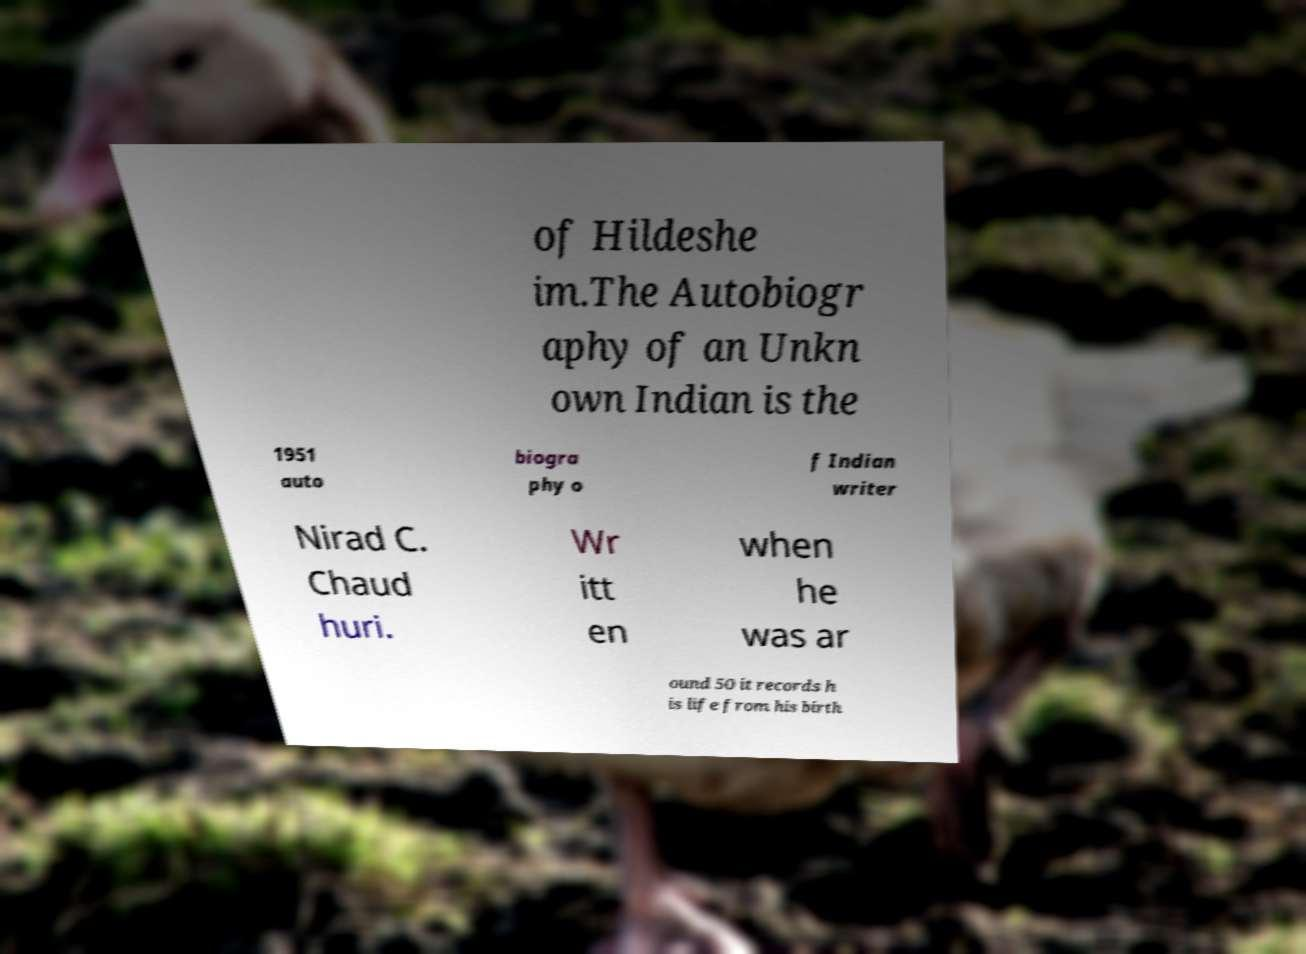I need the written content from this picture converted into text. Can you do that? of Hildeshe im.The Autobiogr aphy of an Unkn own Indian is the 1951 auto biogra phy o f Indian writer Nirad C. Chaud huri. Wr itt en when he was ar ound 50 it records h is life from his birth 